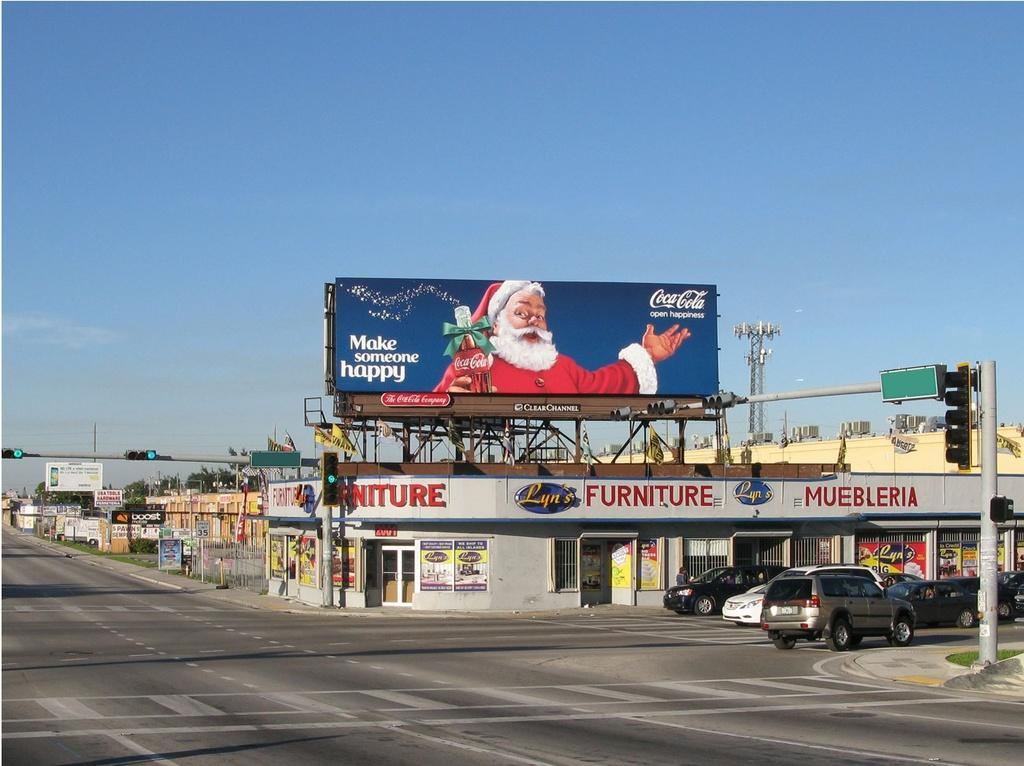<image>
Share a concise interpretation of the image provided. a billboard with Santa that says make someone happy 